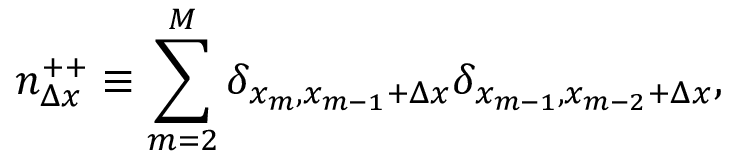<formula> <loc_0><loc_0><loc_500><loc_500>n _ { \Delta x } ^ { + + } \equiv \sum _ { m = 2 } ^ { M } \delta _ { x _ { m } , x _ { m - 1 } + \Delta x } \delta _ { x _ { m - 1 } , x _ { m - 2 } + \Delta x } ,</formula> 